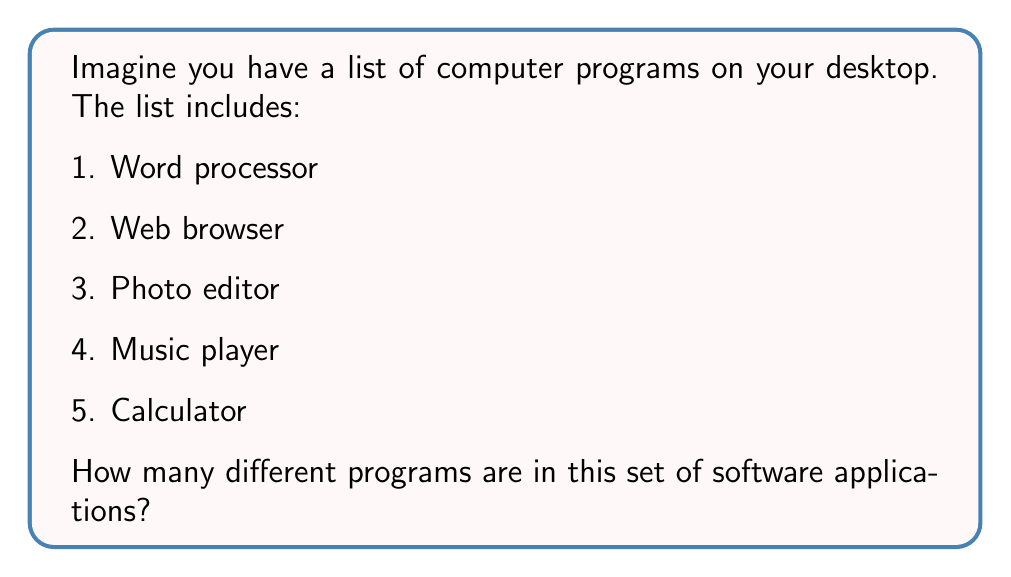Solve this math problem. Let's break this down step-by-step:

1. First, we need to understand what "cardinality" means. In simple terms, it's just the number of items in a set.

2. In this case, our set is the list of software applications on the desktop.

3. To find the cardinality, we just need to count how many unique items are in the set.

4. Let's count the items:
   - Word processor (1)
   - Web browser (2)
   - Photo editor (3)
   - Music player (4)
   - Calculator (5)

5. We can see that there are 5 different programs in the list.

6. In set theory, we write the cardinality of a set A as |A|.

7. So, if we call our set of software applications S, we can write:

   $$|S| = 5$$

This means the cardinality of set S is 5.
Answer: 5 